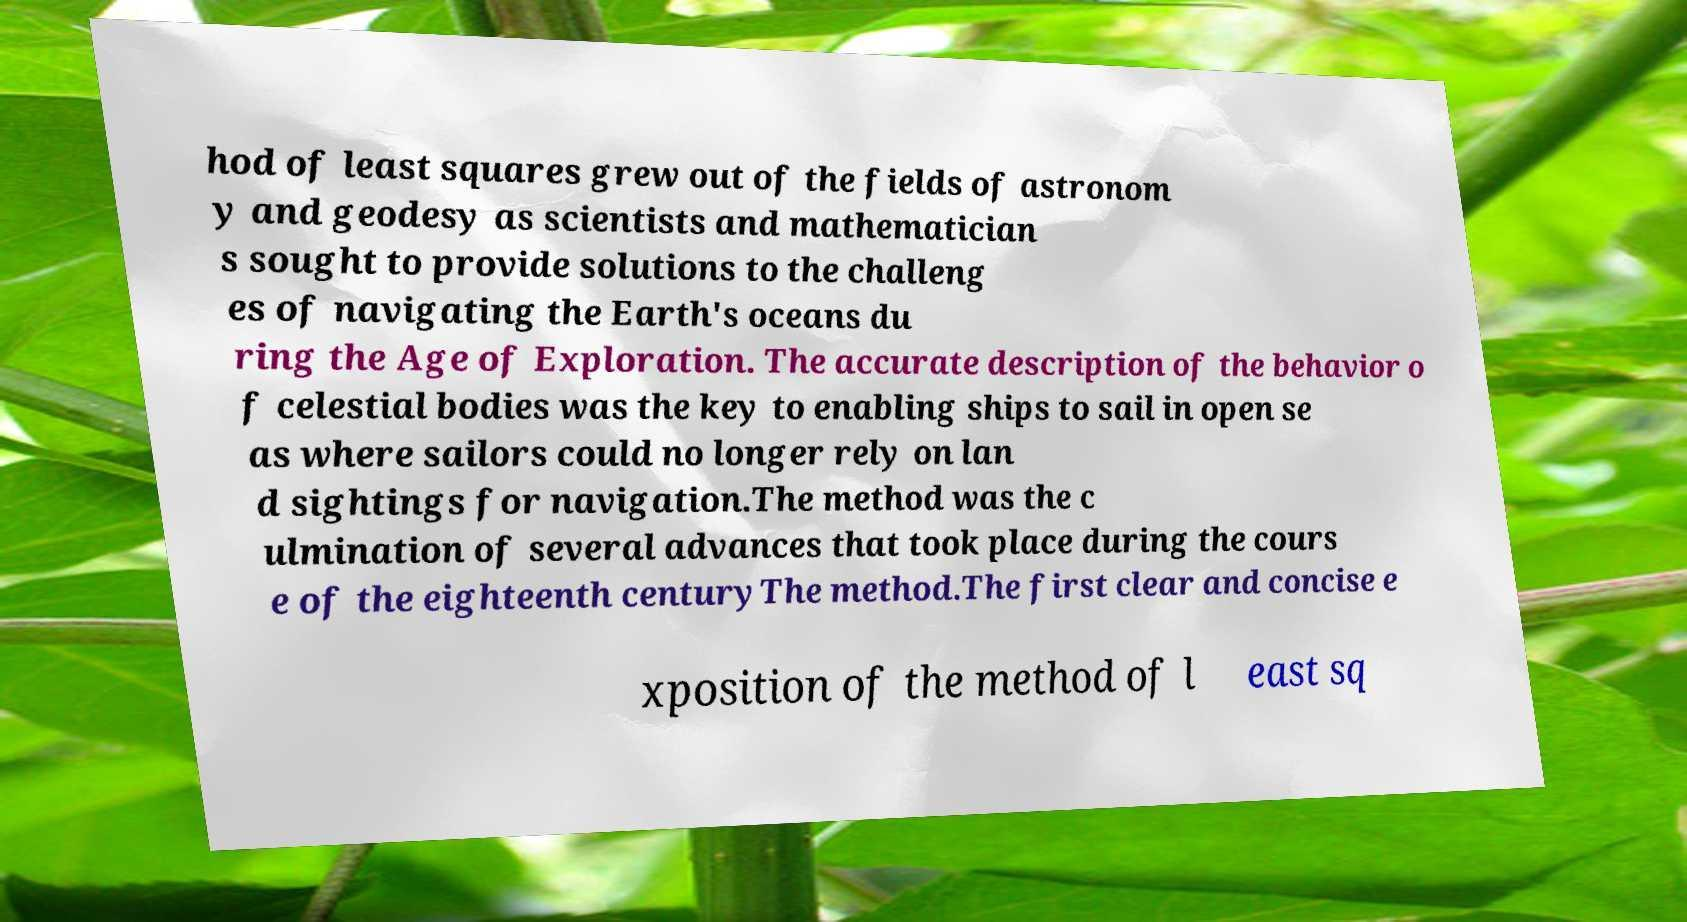I need the written content from this picture converted into text. Can you do that? hod of least squares grew out of the fields of astronom y and geodesy as scientists and mathematician s sought to provide solutions to the challeng es of navigating the Earth's oceans du ring the Age of Exploration. The accurate description of the behavior o f celestial bodies was the key to enabling ships to sail in open se as where sailors could no longer rely on lan d sightings for navigation.The method was the c ulmination of several advances that took place during the cours e of the eighteenth centuryThe method.The first clear and concise e xposition of the method of l east sq 